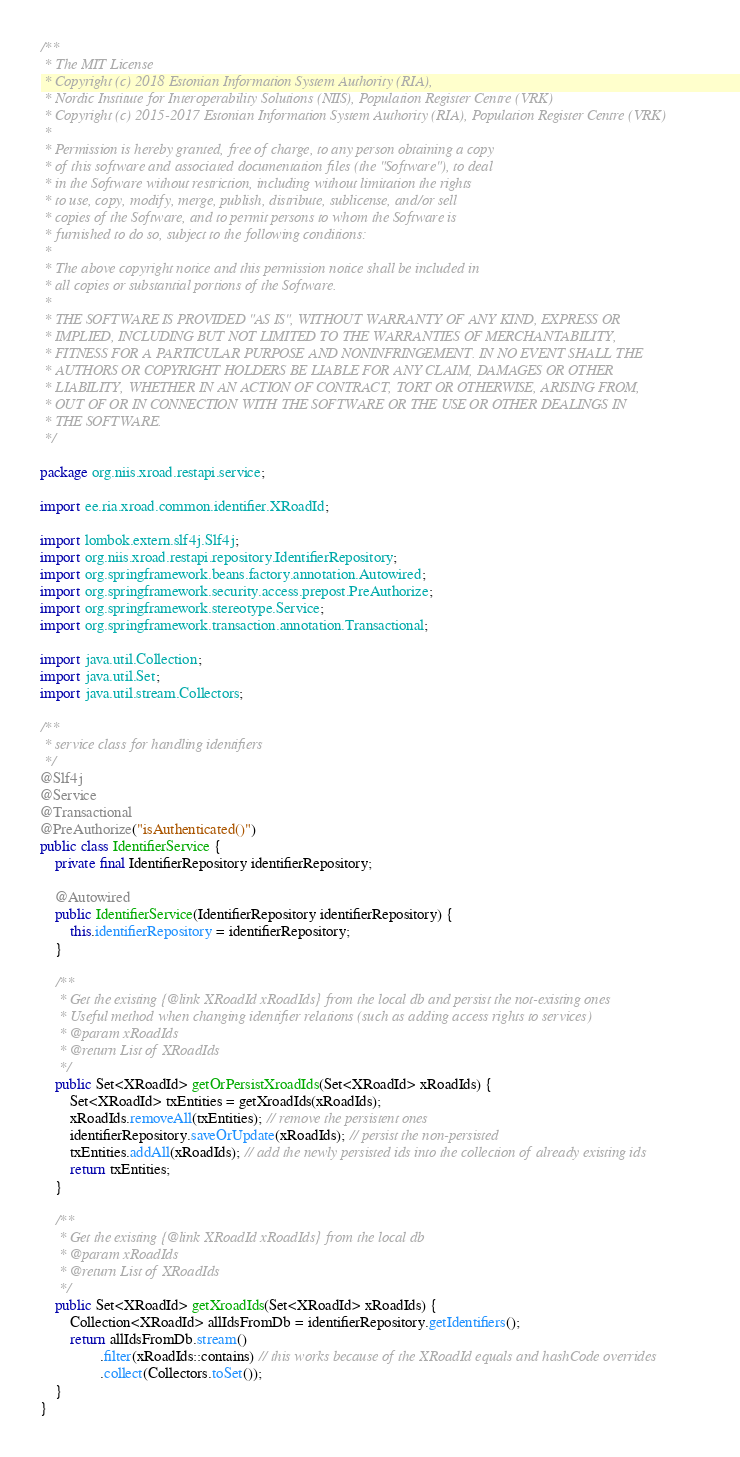<code> <loc_0><loc_0><loc_500><loc_500><_Java_>/**
 * The MIT License
 * Copyright (c) 2018 Estonian Information System Authority (RIA),
 * Nordic Institute for Interoperability Solutions (NIIS), Population Register Centre (VRK)
 * Copyright (c) 2015-2017 Estonian Information System Authority (RIA), Population Register Centre (VRK)
 *
 * Permission is hereby granted, free of charge, to any person obtaining a copy
 * of this software and associated documentation files (the "Software"), to deal
 * in the Software without restriction, including without limitation the rights
 * to use, copy, modify, merge, publish, distribute, sublicense, and/or sell
 * copies of the Software, and to permit persons to whom the Software is
 * furnished to do so, subject to the following conditions:
 *
 * The above copyright notice and this permission notice shall be included in
 * all copies or substantial portions of the Software.
 *
 * THE SOFTWARE IS PROVIDED "AS IS", WITHOUT WARRANTY OF ANY KIND, EXPRESS OR
 * IMPLIED, INCLUDING BUT NOT LIMITED TO THE WARRANTIES OF MERCHANTABILITY,
 * FITNESS FOR A PARTICULAR PURPOSE AND NONINFRINGEMENT. IN NO EVENT SHALL THE
 * AUTHORS OR COPYRIGHT HOLDERS BE LIABLE FOR ANY CLAIM, DAMAGES OR OTHER
 * LIABILITY, WHETHER IN AN ACTION OF CONTRACT, TORT OR OTHERWISE, ARISING FROM,
 * OUT OF OR IN CONNECTION WITH THE SOFTWARE OR THE USE OR OTHER DEALINGS IN
 * THE SOFTWARE.
 */

package org.niis.xroad.restapi.service;

import ee.ria.xroad.common.identifier.XRoadId;

import lombok.extern.slf4j.Slf4j;
import org.niis.xroad.restapi.repository.IdentifierRepository;
import org.springframework.beans.factory.annotation.Autowired;
import org.springframework.security.access.prepost.PreAuthorize;
import org.springframework.stereotype.Service;
import org.springframework.transaction.annotation.Transactional;

import java.util.Collection;
import java.util.Set;
import java.util.stream.Collectors;

/**
 * service class for handling identifiers
 */
@Slf4j
@Service
@Transactional
@PreAuthorize("isAuthenticated()")
public class IdentifierService {
    private final IdentifierRepository identifierRepository;

    @Autowired
    public IdentifierService(IdentifierRepository identifierRepository) {
        this.identifierRepository = identifierRepository;
    }

    /**
     * Get the existing {@link XRoadId xRoadIds} from the local db and persist the not-existing ones
     * Useful method when changing identifier relations (such as adding access rights to services)
     * @param xRoadIds
     * @return List of XRoadIds
     */
    public Set<XRoadId> getOrPersistXroadIds(Set<XRoadId> xRoadIds) {
        Set<XRoadId> txEntities = getXroadIds(xRoadIds);
        xRoadIds.removeAll(txEntities); // remove the persistent ones
        identifierRepository.saveOrUpdate(xRoadIds); // persist the non-persisted
        txEntities.addAll(xRoadIds); // add the newly persisted ids into the collection of already existing ids
        return txEntities;
    }

    /**
     * Get the existing {@link XRoadId xRoadIds} from the local db
     * @param xRoadIds
     * @return List of XRoadIds
     */
    public Set<XRoadId> getXroadIds(Set<XRoadId> xRoadIds) {
        Collection<XRoadId> allIdsFromDb = identifierRepository.getIdentifiers();
        return allIdsFromDb.stream()
                .filter(xRoadIds::contains) // this works because of the XRoadId equals and hashCode overrides
                .collect(Collectors.toSet());
    }
}
</code> 